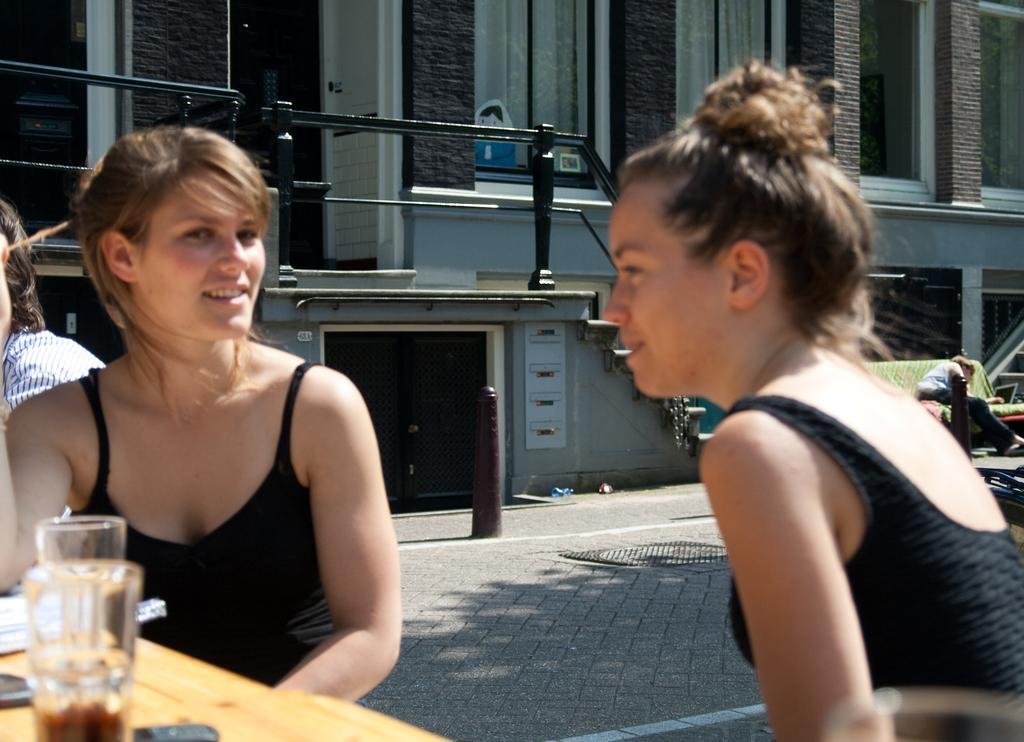How many women are in the image? There are two women in the image. What are the women wearing? The women are wearing black dresses. What can be seen on the table in the image? There are glasses on the table. What is visible in the background of the image? There is a building and a road visible in the image. What time of day is the manager meeting with the stranger in the image? There is no manager or stranger present in the image, and therefore no such a meeting cannot be taking place. 